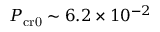Convert formula to latex. <formula><loc_0><loc_0><loc_500><loc_500>P _ { c r 0 } \sim 6 . 2 \times 1 0 ^ { - 2 }</formula> 